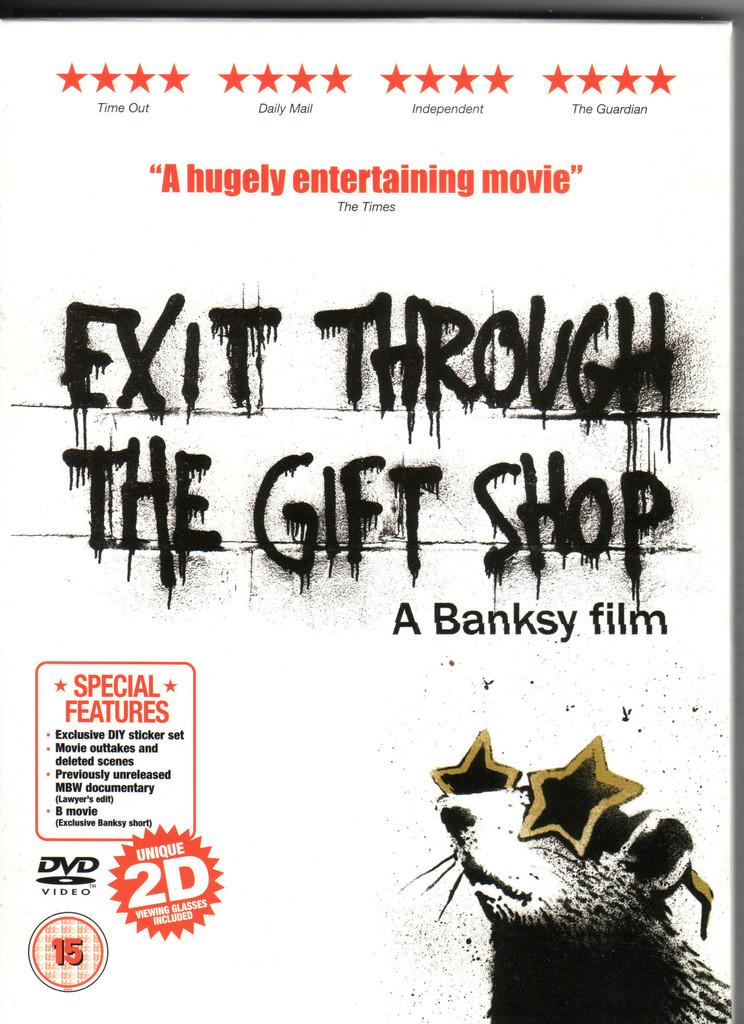What is present in the image related to reading material? There is a magazine in the image. What can be found on the magazine? The magazine has an advertisement on it. What message does the advertisement convey? The advertisement contains the text "exit through the gift shop". What type of chain is holding the magazine in the image? There is no chain present in the image; the magazine is not being held by any visible chain. 